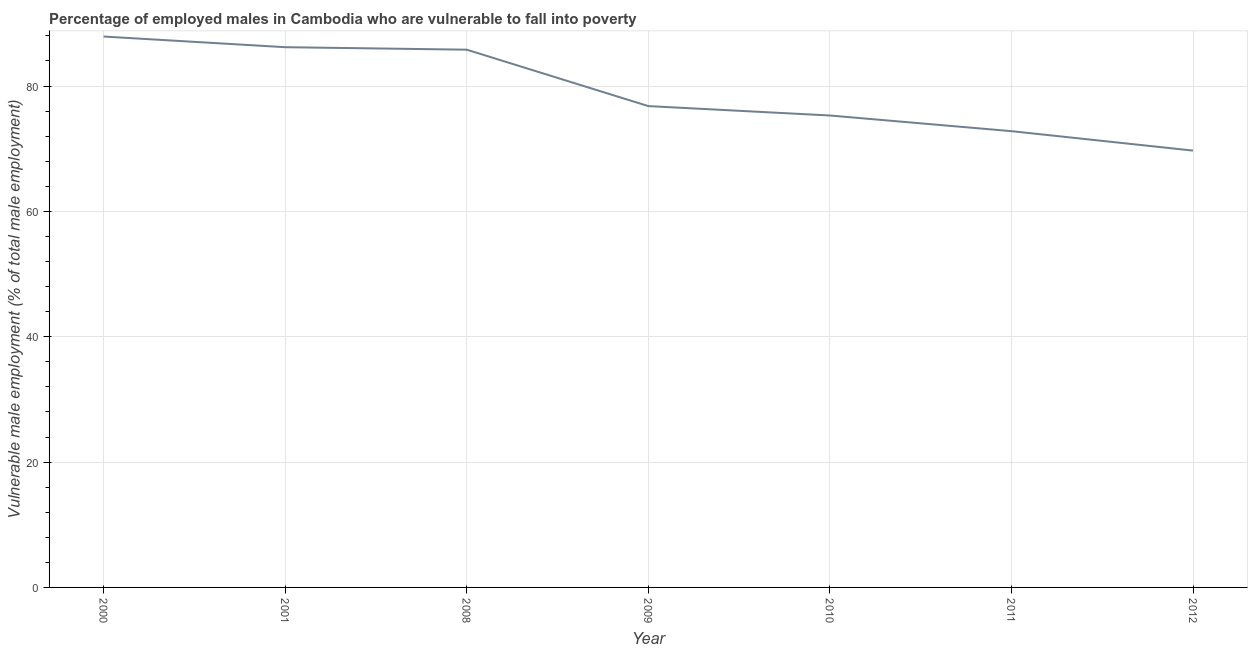What is the percentage of employed males who are vulnerable to fall into poverty in 2009?
Your answer should be very brief. 76.8. Across all years, what is the maximum percentage of employed males who are vulnerable to fall into poverty?
Give a very brief answer. 87.9. Across all years, what is the minimum percentage of employed males who are vulnerable to fall into poverty?
Give a very brief answer. 69.7. In which year was the percentage of employed males who are vulnerable to fall into poverty maximum?
Provide a short and direct response. 2000. What is the sum of the percentage of employed males who are vulnerable to fall into poverty?
Provide a short and direct response. 554.5. What is the difference between the percentage of employed males who are vulnerable to fall into poverty in 2001 and 2010?
Ensure brevity in your answer.  10.9. What is the average percentage of employed males who are vulnerable to fall into poverty per year?
Provide a short and direct response. 79.21. What is the median percentage of employed males who are vulnerable to fall into poverty?
Your answer should be very brief. 76.8. In how many years, is the percentage of employed males who are vulnerable to fall into poverty greater than 40 %?
Provide a short and direct response. 7. Do a majority of the years between 2010 and 2000 (inclusive) have percentage of employed males who are vulnerable to fall into poverty greater than 36 %?
Provide a succinct answer. Yes. What is the ratio of the percentage of employed males who are vulnerable to fall into poverty in 2000 to that in 2011?
Keep it short and to the point. 1.21. Is the percentage of employed males who are vulnerable to fall into poverty in 2011 less than that in 2012?
Your response must be concise. No. What is the difference between the highest and the second highest percentage of employed males who are vulnerable to fall into poverty?
Your response must be concise. 1.7. Is the sum of the percentage of employed males who are vulnerable to fall into poverty in 2000 and 2010 greater than the maximum percentage of employed males who are vulnerable to fall into poverty across all years?
Your answer should be very brief. Yes. What is the difference between the highest and the lowest percentage of employed males who are vulnerable to fall into poverty?
Provide a succinct answer. 18.2. In how many years, is the percentage of employed males who are vulnerable to fall into poverty greater than the average percentage of employed males who are vulnerable to fall into poverty taken over all years?
Provide a short and direct response. 3. How many years are there in the graph?
Keep it short and to the point. 7. What is the difference between two consecutive major ticks on the Y-axis?
Offer a very short reply. 20. Are the values on the major ticks of Y-axis written in scientific E-notation?
Give a very brief answer. No. Does the graph contain any zero values?
Give a very brief answer. No. Does the graph contain grids?
Your answer should be very brief. Yes. What is the title of the graph?
Make the answer very short. Percentage of employed males in Cambodia who are vulnerable to fall into poverty. What is the label or title of the X-axis?
Offer a terse response. Year. What is the label or title of the Y-axis?
Provide a short and direct response. Vulnerable male employment (% of total male employment). What is the Vulnerable male employment (% of total male employment) in 2000?
Offer a very short reply. 87.9. What is the Vulnerable male employment (% of total male employment) of 2001?
Offer a very short reply. 86.2. What is the Vulnerable male employment (% of total male employment) in 2008?
Your answer should be very brief. 85.8. What is the Vulnerable male employment (% of total male employment) in 2009?
Your response must be concise. 76.8. What is the Vulnerable male employment (% of total male employment) of 2010?
Provide a succinct answer. 75.3. What is the Vulnerable male employment (% of total male employment) of 2011?
Your answer should be very brief. 72.8. What is the Vulnerable male employment (% of total male employment) of 2012?
Offer a terse response. 69.7. What is the difference between the Vulnerable male employment (% of total male employment) in 2000 and 2008?
Offer a very short reply. 2.1. What is the difference between the Vulnerable male employment (% of total male employment) in 2000 and 2012?
Provide a succinct answer. 18.2. What is the difference between the Vulnerable male employment (% of total male employment) in 2001 and 2008?
Your response must be concise. 0.4. What is the difference between the Vulnerable male employment (% of total male employment) in 2001 and 2009?
Offer a terse response. 9.4. What is the difference between the Vulnerable male employment (% of total male employment) in 2001 and 2010?
Keep it short and to the point. 10.9. What is the difference between the Vulnerable male employment (% of total male employment) in 2001 and 2011?
Ensure brevity in your answer.  13.4. What is the difference between the Vulnerable male employment (% of total male employment) in 2008 and 2009?
Ensure brevity in your answer.  9. What is the difference between the Vulnerable male employment (% of total male employment) in 2008 and 2011?
Make the answer very short. 13. What is the difference between the Vulnerable male employment (% of total male employment) in 2008 and 2012?
Keep it short and to the point. 16.1. What is the difference between the Vulnerable male employment (% of total male employment) in 2009 and 2010?
Your answer should be very brief. 1.5. What is the difference between the Vulnerable male employment (% of total male employment) in 2009 and 2012?
Ensure brevity in your answer.  7.1. What is the difference between the Vulnerable male employment (% of total male employment) in 2010 and 2012?
Provide a succinct answer. 5.6. What is the difference between the Vulnerable male employment (% of total male employment) in 2011 and 2012?
Ensure brevity in your answer.  3.1. What is the ratio of the Vulnerable male employment (% of total male employment) in 2000 to that in 2008?
Keep it short and to the point. 1.02. What is the ratio of the Vulnerable male employment (% of total male employment) in 2000 to that in 2009?
Provide a short and direct response. 1.15. What is the ratio of the Vulnerable male employment (% of total male employment) in 2000 to that in 2010?
Provide a succinct answer. 1.17. What is the ratio of the Vulnerable male employment (% of total male employment) in 2000 to that in 2011?
Make the answer very short. 1.21. What is the ratio of the Vulnerable male employment (% of total male employment) in 2000 to that in 2012?
Your answer should be compact. 1.26. What is the ratio of the Vulnerable male employment (% of total male employment) in 2001 to that in 2009?
Give a very brief answer. 1.12. What is the ratio of the Vulnerable male employment (% of total male employment) in 2001 to that in 2010?
Your response must be concise. 1.15. What is the ratio of the Vulnerable male employment (% of total male employment) in 2001 to that in 2011?
Offer a very short reply. 1.18. What is the ratio of the Vulnerable male employment (% of total male employment) in 2001 to that in 2012?
Provide a short and direct response. 1.24. What is the ratio of the Vulnerable male employment (% of total male employment) in 2008 to that in 2009?
Your answer should be very brief. 1.12. What is the ratio of the Vulnerable male employment (% of total male employment) in 2008 to that in 2010?
Offer a very short reply. 1.14. What is the ratio of the Vulnerable male employment (% of total male employment) in 2008 to that in 2011?
Give a very brief answer. 1.18. What is the ratio of the Vulnerable male employment (% of total male employment) in 2008 to that in 2012?
Offer a very short reply. 1.23. What is the ratio of the Vulnerable male employment (% of total male employment) in 2009 to that in 2011?
Your answer should be compact. 1.05. What is the ratio of the Vulnerable male employment (% of total male employment) in 2009 to that in 2012?
Give a very brief answer. 1.1. What is the ratio of the Vulnerable male employment (% of total male employment) in 2010 to that in 2011?
Your answer should be very brief. 1.03. What is the ratio of the Vulnerable male employment (% of total male employment) in 2010 to that in 2012?
Provide a short and direct response. 1.08. What is the ratio of the Vulnerable male employment (% of total male employment) in 2011 to that in 2012?
Your answer should be very brief. 1.04. 